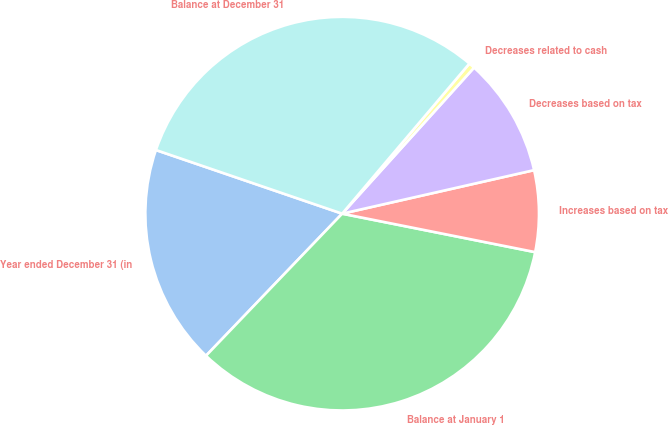Convert chart. <chart><loc_0><loc_0><loc_500><loc_500><pie_chart><fcel>Year ended December 31 (in<fcel>Balance at January 1<fcel>Increases based on tax<fcel>Decreases based on tax<fcel>Decreases related to cash<fcel>Balance at December 31<nl><fcel>18.08%<fcel>34.03%<fcel>6.68%<fcel>9.76%<fcel>0.5%<fcel>30.95%<nl></chart> 